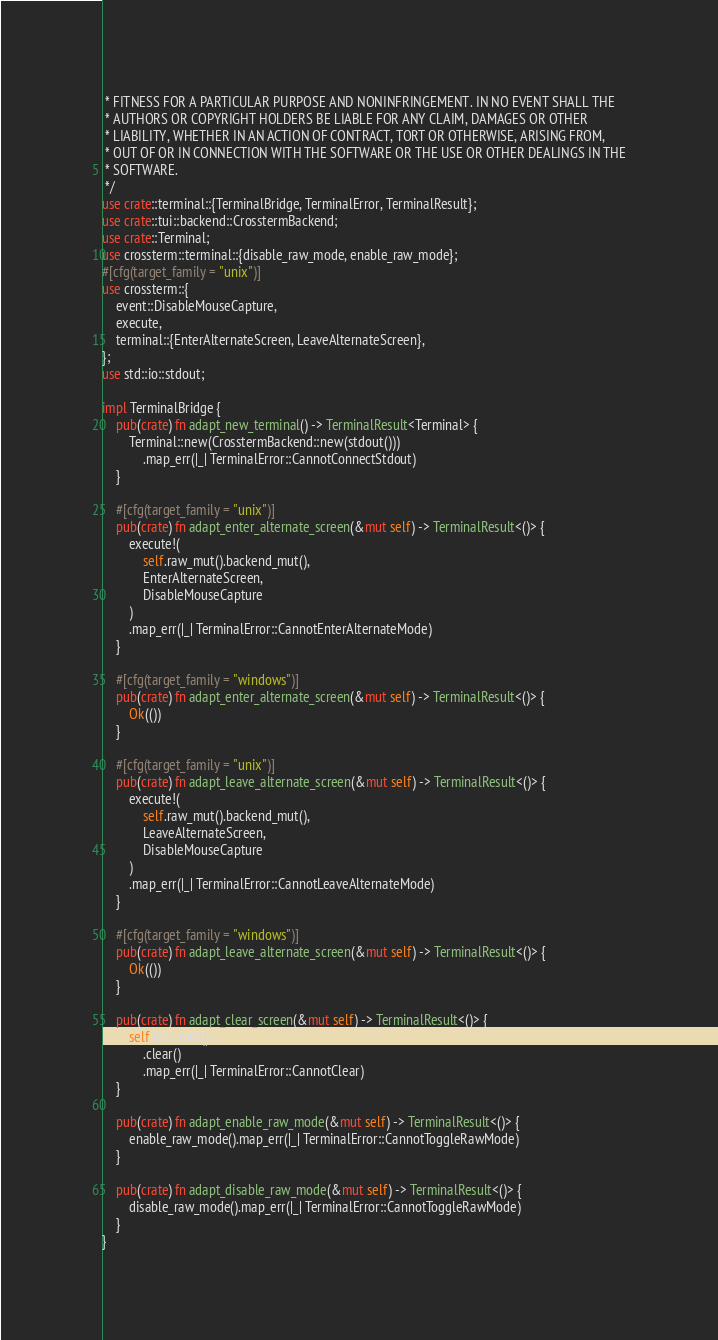<code> <loc_0><loc_0><loc_500><loc_500><_Rust_> * FITNESS FOR A PARTICULAR PURPOSE AND NONINFRINGEMENT. IN NO EVENT SHALL THE
 * AUTHORS OR COPYRIGHT HOLDERS BE LIABLE FOR ANY CLAIM, DAMAGES OR OTHER
 * LIABILITY, WHETHER IN AN ACTION OF CONTRACT, TORT OR OTHERWISE, ARISING FROM,
 * OUT OF OR IN CONNECTION WITH THE SOFTWARE OR THE USE OR OTHER DEALINGS IN THE
 * SOFTWARE.
 */
use crate::terminal::{TerminalBridge, TerminalError, TerminalResult};
use crate::tui::backend::CrosstermBackend;
use crate::Terminal;
use crossterm::terminal::{disable_raw_mode, enable_raw_mode};
#[cfg(target_family = "unix")]
use crossterm::{
    event::DisableMouseCapture,
    execute,
    terminal::{EnterAlternateScreen, LeaveAlternateScreen},
};
use std::io::stdout;

impl TerminalBridge {
    pub(crate) fn adapt_new_terminal() -> TerminalResult<Terminal> {
        Terminal::new(CrosstermBackend::new(stdout()))
            .map_err(|_| TerminalError::CannotConnectStdout)
    }

    #[cfg(target_family = "unix")]
    pub(crate) fn adapt_enter_alternate_screen(&mut self) -> TerminalResult<()> {
        execute!(
            self.raw_mut().backend_mut(),
            EnterAlternateScreen,
            DisableMouseCapture
        )
        .map_err(|_| TerminalError::CannotEnterAlternateMode)
    }

    #[cfg(target_family = "windows")]
    pub(crate) fn adapt_enter_alternate_screen(&mut self) -> TerminalResult<()> {
        Ok(())
    }

    #[cfg(target_family = "unix")]
    pub(crate) fn adapt_leave_alternate_screen(&mut self) -> TerminalResult<()> {
        execute!(
            self.raw_mut().backend_mut(),
            LeaveAlternateScreen,
            DisableMouseCapture
        )
        .map_err(|_| TerminalError::CannotLeaveAlternateMode)
    }

    #[cfg(target_family = "windows")]
    pub(crate) fn adapt_leave_alternate_screen(&mut self) -> TerminalResult<()> {
        Ok(())
    }

    pub(crate) fn adapt_clear_screen(&mut self) -> TerminalResult<()> {
        self.raw_mut()
            .clear()
            .map_err(|_| TerminalError::CannotClear)
    }

    pub(crate) fn adapt_enable_raw_mode(&mut self) -> TerminalResult<()> {
        enable_raw_mode().map_err(|_| TerminalError::CannotToggleRawMode)
    }

    pub(crate) fn adapt_disable_raw_mode(&mut self) -> TerminalResult<()> {
        disable_raw_mode().map_err(|_| TerminalError::CannotToggleRawMode)
    }
}
</code> 